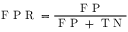Convert formula to latex. <formula><loc_0><loc_0><loc_500><loc_500>F P R = \frac { F P } { F P + T N }</formula> 